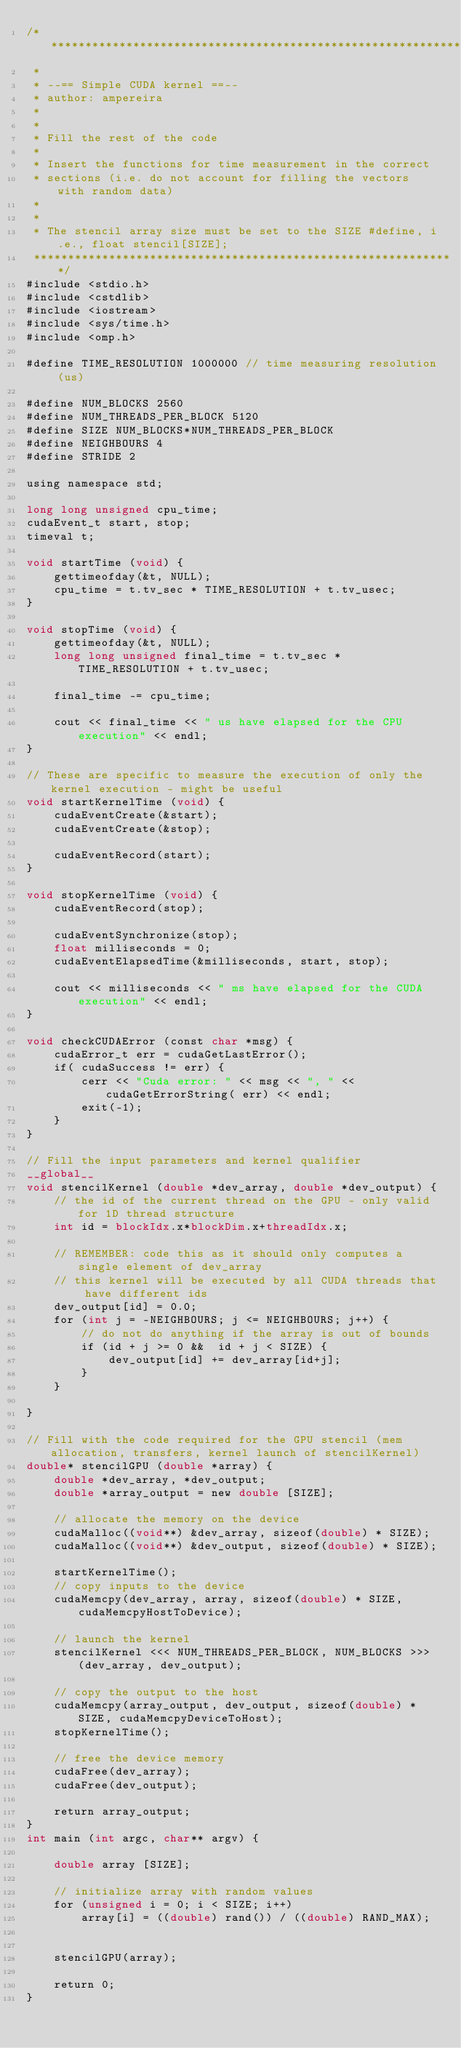<code> <loc_0><loc_0><loc_500><loc_500><_Cuda_>/**************************************************************
 *
 * --== Simple CUDA kernel ==--
 * author: ampereira
 *
 *
 * Fill the rest of the code
 *
 * Insert the functions for time measurement in the correct
 * sections (i.e. do not account for filling the vectors with random data)
 *
 *
 * The stencil array size must be set to the SIZE #define, i.e., float stencil[SIZE];
 **************************************************************/
#include <stdio.h>
#include <cstdlib>
#include <iostream>
#include <sys/time.h>
#include <omp.h>

#define TIME_RESOLUTION 1000000	// time measuring resolution (us)

#define NUM_BLOCKS 2560
#define NUM_THREADS_PER_BLOCK 5120
#define SIZE NUM_BLOCKS*NUM_THREADS_PER_BLOCK
#define NEIGHBOURS 4
#define STRIDE 2

using namespace std;

long long unsigned cpu_time;
cudaEvent_t start, stop;
timeval t;

void startTime (void) {
    gettimeofday(&t, NULL);
    cpu_time = t.tv_sec * TIME_RESOLUTION + t.tv_usec;
}

void stopTime (void) {
    gettimeofday(&t, NULL);
    long long unsigned final_time = t.tv_sec * TIME_RESOLUTION + t.tv_usec;

    final_time -= cpu_time;

    cout << final_time << " us have elapsed for the CPU execution" << endl;
}

// These are specific to measure the execution of only the kernel execution - might be useful
void startKernelTime (void) {
    cudaEventCreate(&start);
    cudaEventCreate(&stop);

    cudaEventRecord(start);
}

void stopKernelTime (void) {
    cudaEventRecord(stop);

    cudaEventSynchronize(stop);
    float milliseconds = 0;
    cudaEventElapsedTime(&milliseconds, start, stop);

    cout << milliseconds << " ms have elapsed for the CUDA execution" << endl;
}

void checkCUDAError (const char *msg) {
    cudaError_t err = cudaGetLastError();
    if( cudaSuccess != err) {
        cerr << "Cuda error: " << msg << ", " << cudaGetErrorString( err) << endl;
        exit(-1);
    }
}

// Fill the input parameters and kernel qualifier
__global__
void stencilKernel (double *dev_array, double *dev_output) {
    // the id of the current thread on the GPU - only valid for 1D thread structure
    int id = blockIdx.x*blockDim.x+threadIdx.x;

    // REMEMBER: code this as it should only computes a single element of dev_array
    // this kernel will be executed by all CUDA threads that have different ids
    dev_output[id] = 0.0;
    for (int j = -NEIGHBOURS; j <= NEIGHBOURS; j++) {
        // do not do anything if the array is out of bounds
        if (id + j >= 0 &&  id + j < SIZE) {
            dev_output[id] += dev_array[id+j];
        }
    }

}

// Fill with the code required for the GPU stencil (mem allocation, transfers, kernel launch of stencilKernel)
double* stencilGPU (double *array) {
    double *dev_array, *dev_output;
    double *array_output = new double [SIZE];

    // allocate the memory on the device
    cudaMalloc((void**) &dev_array, sizeof(double) * SIZE);
    cudaMalloc((void**) &dev_output, sizeof(double) * SIZE);

    startKernelTime();
    // copy inputs to the device
    cudaMemcpy(dev_array, array, sizeof(double) * SIZE, cudaMemcpyHostToDevice);

    // launch the kernel
    stencilKernel <<< NUM_THREADS_PER_BLOCK, NUM_BLOCKS >>> (dev_array, dev_output);

    // copy the output to the host
    cudaMemcpy(array_output, dev_output, sizeof(double) * SIZE, cudaMemcpyDeviceToHost);
    stopKernelTime();

    // free the device memory
    cudaFree(dev_array);
    cudaFree(dev_output);

    return array_output;
}
int main (int argc, char** argv) {

    double array [SIZE];

    // initialize array with random values
    for (unsigned i = 0; i < SIZE; i++)
        array[i] = ((double) rand()) / ((double) RAND_MAX);


    stencilGPU(array);

    return 0;
}
</code> 